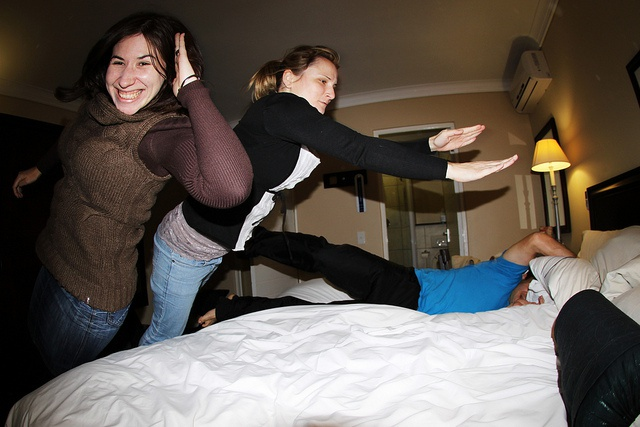Describe the objects in this image and their specific colors. I can see bed in black, lightgray, darkgray, and gray tones, people in black, maroon, and brown tones, people in black, darkgray, lightgray, and gray tones, and people in black, teal, and gray tones in this image. 